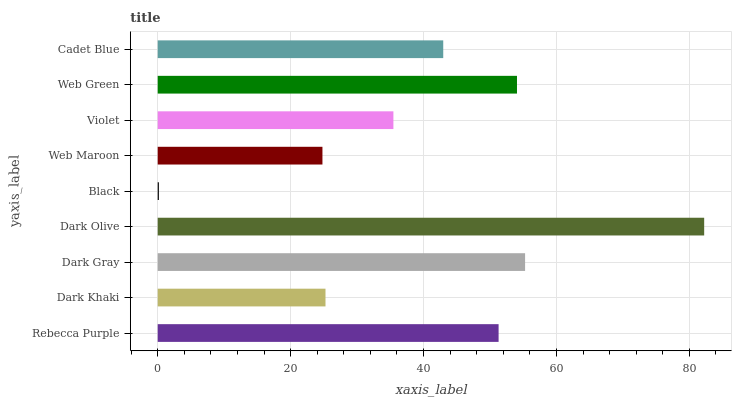Is Black the minimum?
Answer yes or no. Yes. Is Dark Olive the maximum?
Answer yes or no. Yes. Is Dark Khaki the minimum?
Answer yes or no. No. Is Dark Khaki the maximum?
Answer yes or no. No. Is Rebecca Purple greater than Dark Khaki?
Answer yes or no. Yes. Is Dark Khaki less than Rebecca Purple?
Answer yes or no. Yes. Is Dark Khaki greater than Rebecca Purple?
Answer yes or no. No. Is Rebecca Purple less than Dark Khaki?
Answer yes or no. No. Is Cadet Blue the high median?
Answer yes or no. Yes. Is Cadet Blue the low median?
Answer yes or no. Yes. Is Black the high median?
Answer yes or no. No. Is Web Green the low median?
Answer yes or no. No. 